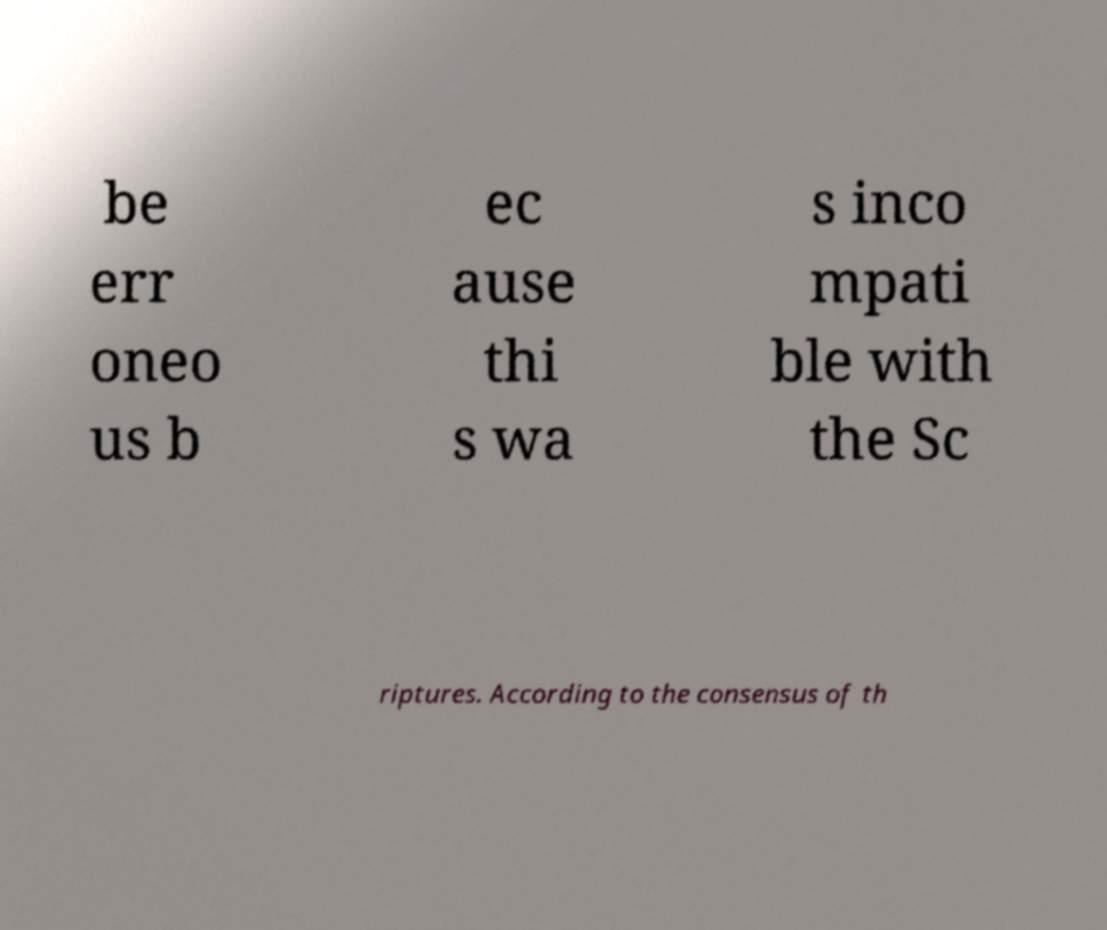For documentation purposes, I need the text within this image transcribed. Could you provide that? be err oneo us b ec ause thi s wa s inco mpati ble with the Sc riptures. According to the consensus of th 